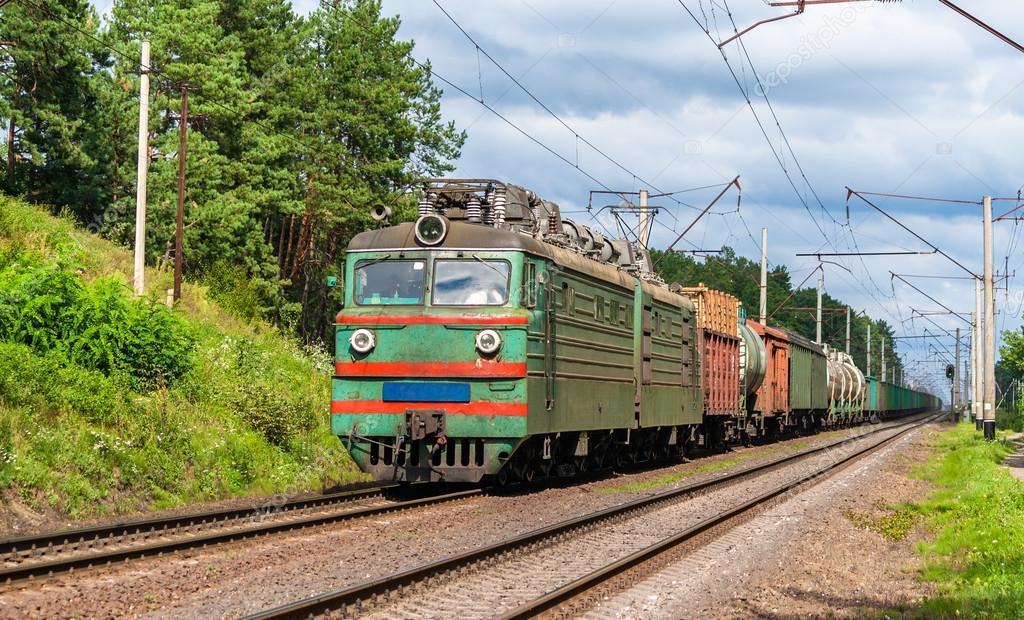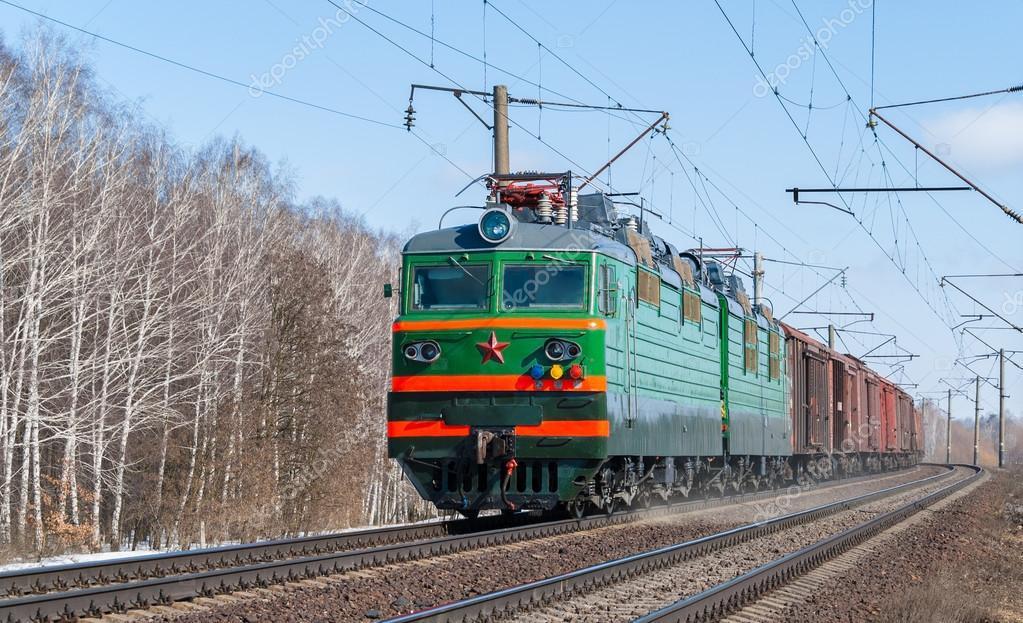The first image is the image on the left, the second image is the image on the right. Given the left and right images, does the statement "At least one image shows a green train with red-orange trim pulling a line of freight cars." hold true? Answer yes or no. Yes. 